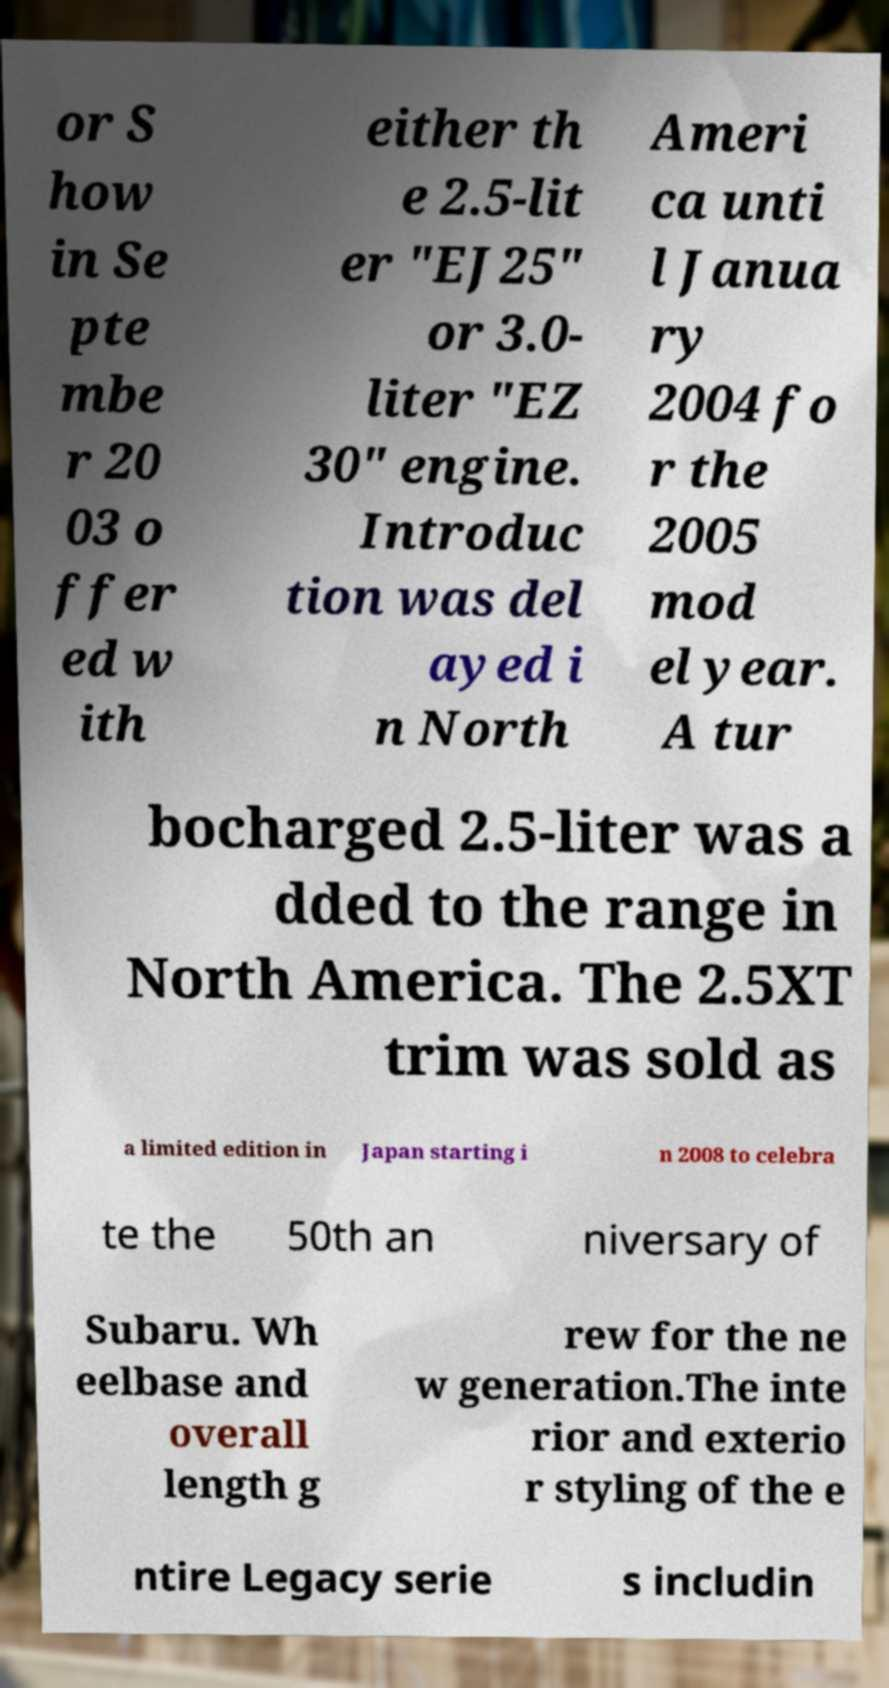I need the written content from this picture converted into text. Can you do that? or S how in Se pte mbe r 20 03 o ffer ed w ith either th e 2.5-lit er "EJ25" or 3.0- liter "EZ 30" engine. Introduc tion was del ayed i n North Ameri ca unti l Janua ry 2004 fo r the 2005 mod el year. A tur bocharged 2.5-liter was a dded to the range in North America. The 2.5XT trim was sold as a limited edition in Japan starting i n 2008 to celebra te the 50th an niversary of Subaru. Wh eelbase and overall length g rew for the ne w generation.The inte rior and exterio r styling of the e ntire Legacy serie s includin 